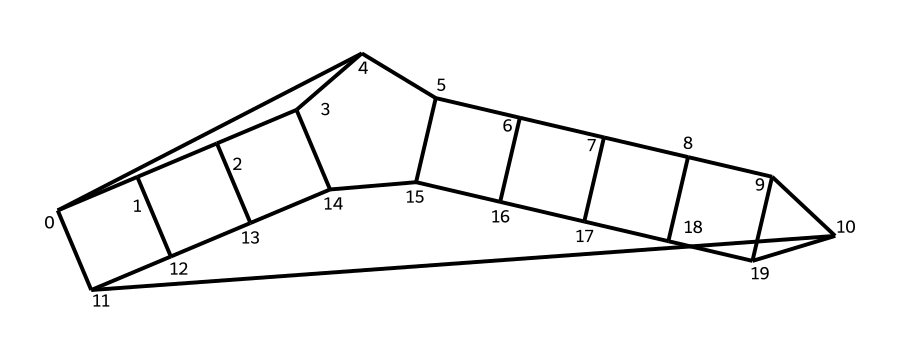How many carbon atoms are in dodecahedrane? The structural formula represented by the SMILES contains a total of twelve carbon atoms. Each 'C' in the SMILES notation corresponds to a carbon atom.
Answer: twelve What is the total number of bonds in dodecahedrane? The structure of dodecahedrane shows twelve carbon atoms interconnected in a complex manner. It's a highly symmetrical cage compound where each carbon atom is typically bonded to two other carbon atoms, resulting in numerous bonds. Closer examination reveals 30 total bonds within the compound, given the cage structure.
Answer: thirty What is the molecular formula of dodecahedrane? By counting the carbon atoms and knowing the molecular structure follows CnH2n pattern for saturated hydrocarbons, we conclude the molecular formula is C12H24 because there are 12 carbon atoms.
Answer: C12H24 Is dodecahedrane a saturated hydrocarbon? The structure indicates that all carbon atoms are connected by single bonds and follow the general formula for saturated compounds, which are hydrocarbons containing only single bonds. Therefore, it qualifies as a saturated hydrocarbon.
Answer: yes What type of compound is dodecahedrane? The structure demonstrates characteristics of cage compounds, specifically showing a three-dimensional structure that fits the definition of a cage molecule due to its highly symmetrical nature and closed framework.
Answer: cage compound What is the significance of dodecahedrane in energy storage? Dodecahedrane’s symmetrical structure and stable configuration make it a candidate for energy storage research, as its molecular geometry can potentially allow for high energy capacity and efficient energy release.
Answer: energy storage How many symmetrical planes does dodecahedrane have? The highly symmetrical structure of dodecahedrane allows for multiple planes of symmetry; specifically, there are at least five distinct mirror planes due to the arrangement of carbon atoms.
Answer: five 